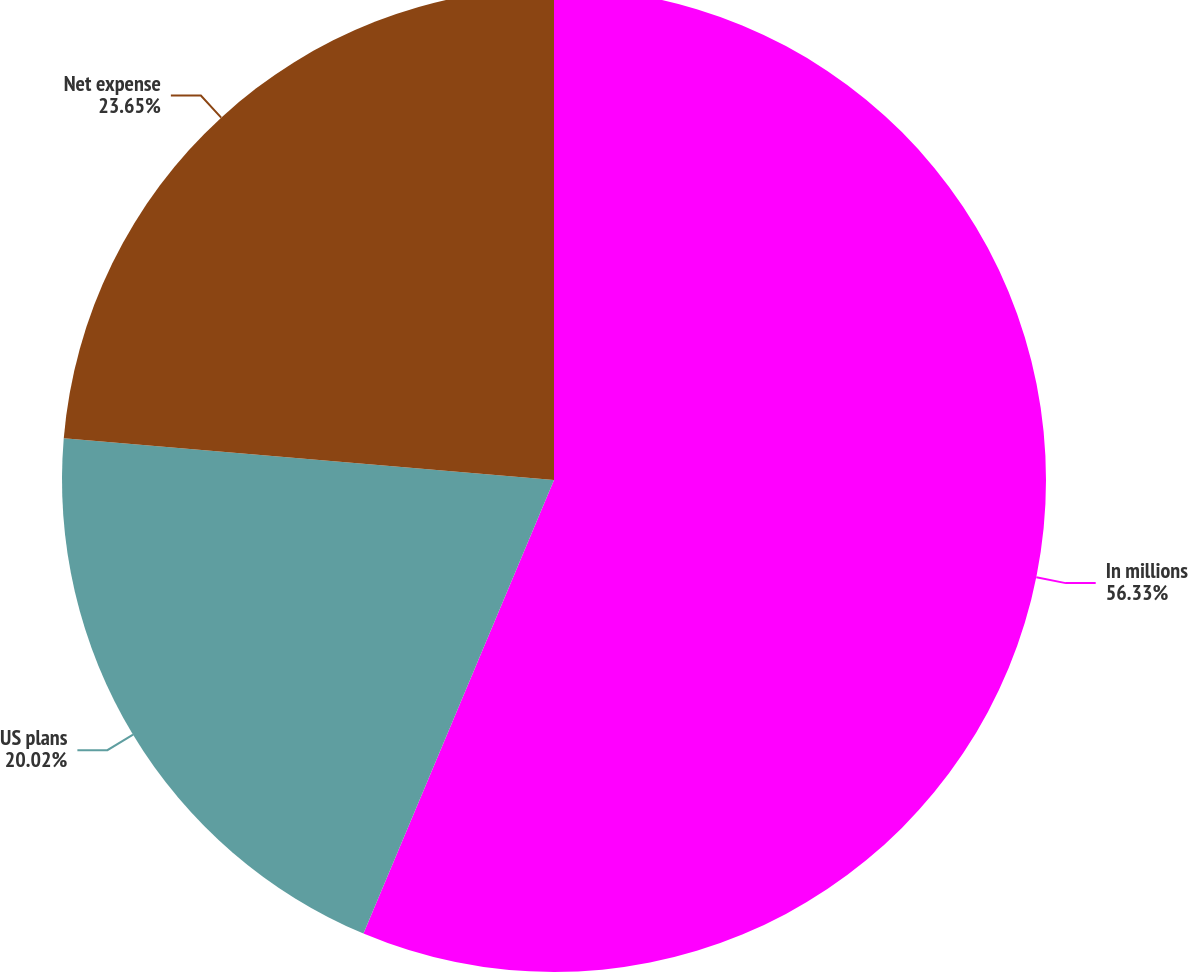Convert chart. <chart><loc_0><loc_0><loc_500><loc_500><pie_chart><fcel>In millions<fcel>US plans<fcel>Net expense<nl><fcel>56.33%<fcel>20.02%<fcel>23.65%<nl></chart> 